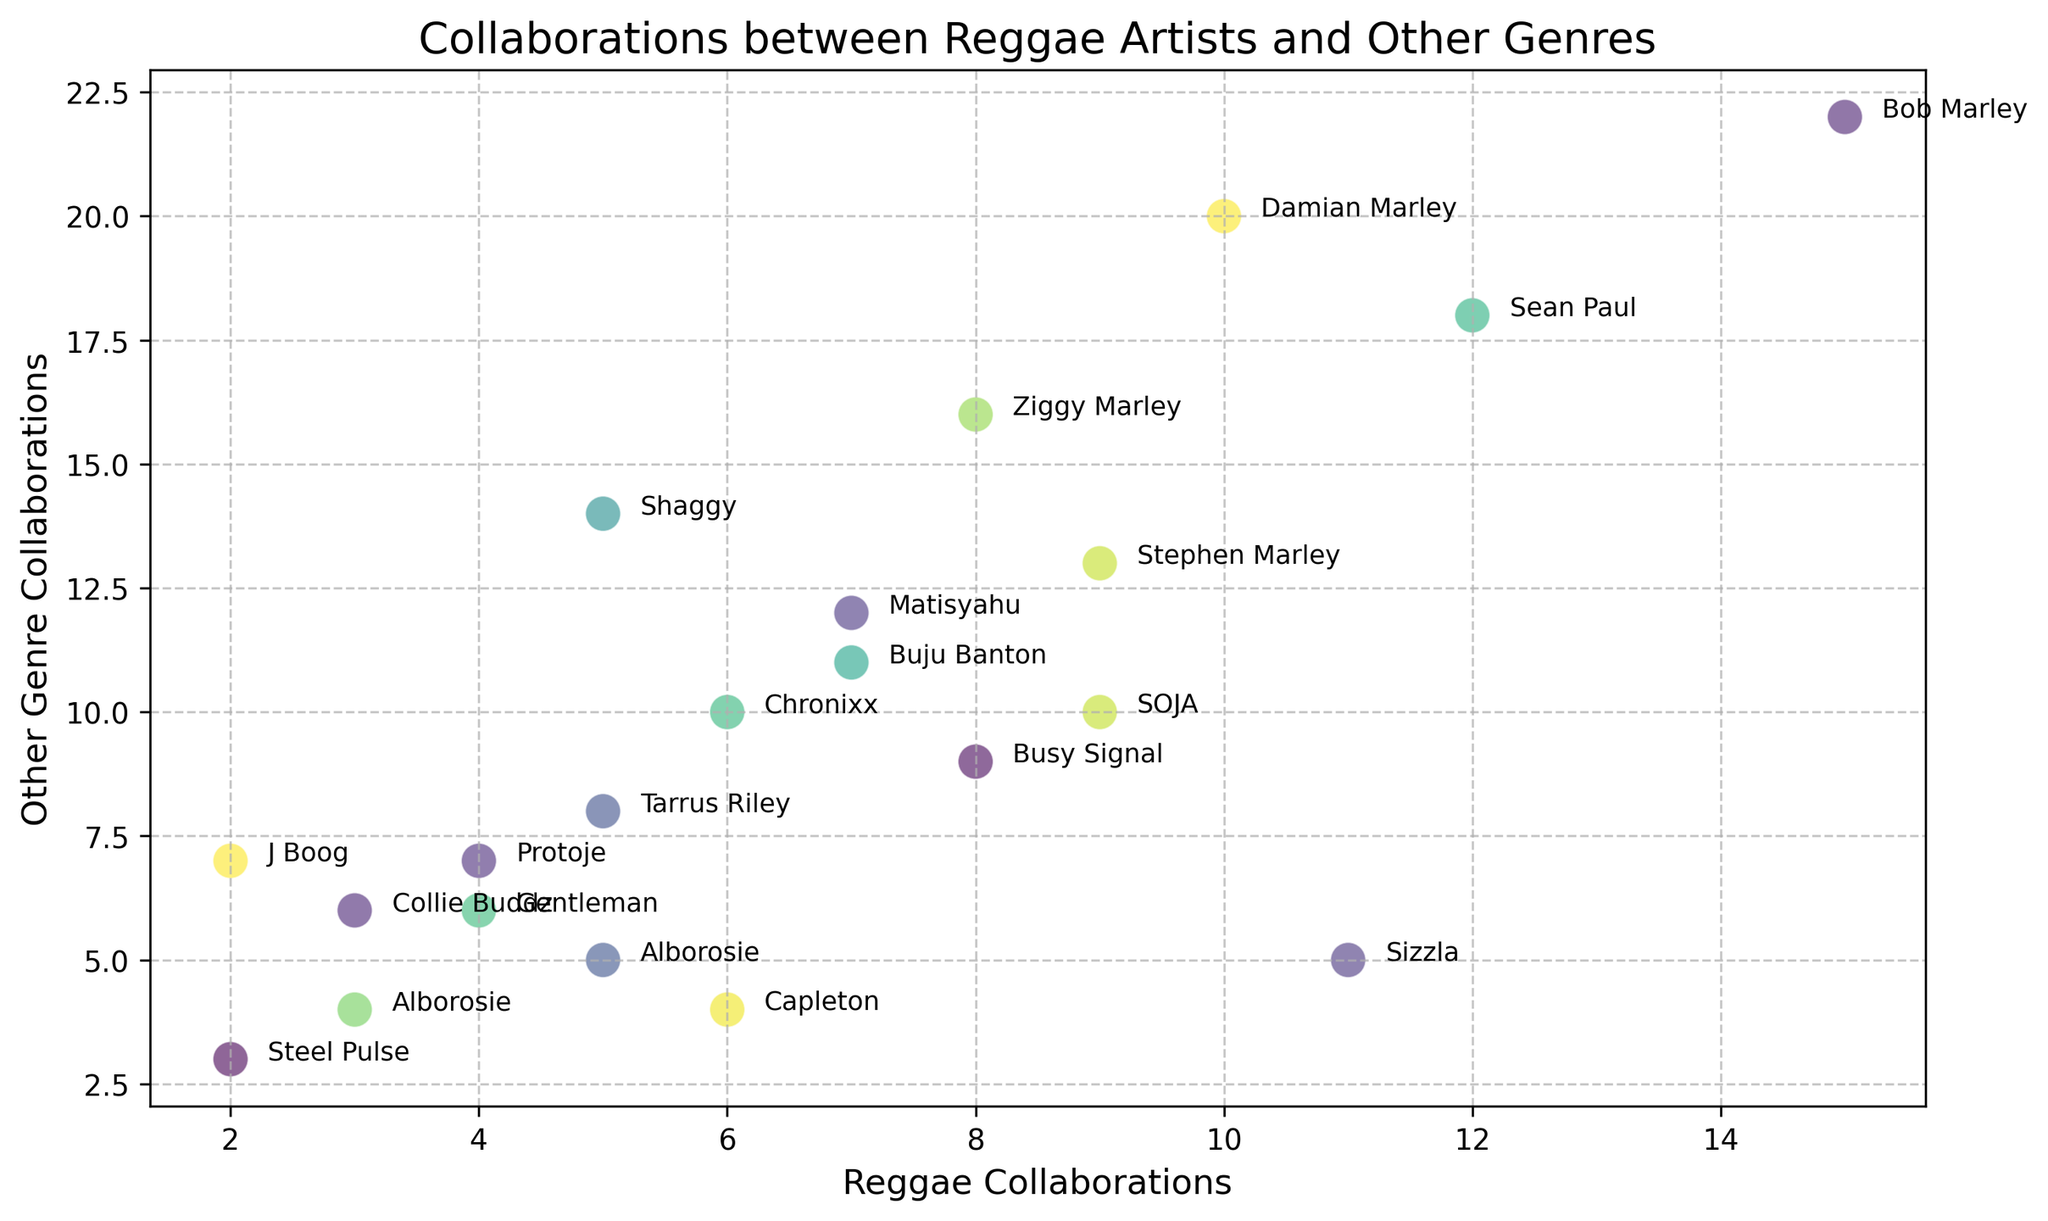What is the total number of reggae collaboration singles for artists who have also released at least 15 singles in other genres? First, identify the artists with at least 15 singles in other genres: Bob Marley (22), Sean Paul (18), Damian Marley (20), and Ziggy Marley (16). Then sum their reggae collaborations: 15 (Bob Marley) + 12 (Sean Paul) + 10 (Damian Marley) + 8 (Ziggy Marley) = 45.
Answer: 45 Which artist has the most number of singles in other genres? Look at the data points to identify which artist has the highest Y-coordinate value. Bob Marley is at the highest position with 22 singles in other genres.
Answer: Bob Marley Who has more reggae collaboration singles: Stephen Marley or Tarrus Riley? Compare the X-coordinate values for Stephen Marley (9) and Tarrus Riley (5). Stephen Marley has more reggae collaboration singles.
Answer: Stephen Marley Which artist has the closest number of reggae and other genre collaboration singles? Look for the data point where the X and Y values are closest. Gentleman has 4 reggae and 6 other genre singles, a difference of 2, which is the closest.
Answer: Gentleman What is the average number of other genre singles for the artists with at least 10 reggae collaboration singles? Identify the artists with at least 10 reggae singles: Bob Marley (15), Sean Paul (12), Damian Marley (10), Sizzla (11). Now, average their other genre singles: (22 + 18 + 20 + 5) / 4 = 16.25.
Answer: 16.25 Which artist with fewer than 10 reggae collaboration singles has collaborated the least in other genres? Identify artists with fewer than 10 reggae singles: Shaggy, Tarrus Riley, Protoje, Steel Pulse, Collie Buddz, J Boog, Alborosie, Gentleman, Matisyahu, Chronixx, Buju Banton. Of these, Steel Pulse has the least with 3 other genre singles.
Answer: Steel Pulse Who are the artists clustered towards the bottom right of the scatter plot? Look towards the segment of the plot with low X values but relatively high Y values. J Boog, Protoje, and Shaggy are clustered in this region.
Answer: J Boog, Protoje, Shaggy What is the difference in the number of other genre singles between Sizzla and J Boog? Sizzla has 5 other genre singles and J Boog has 7. The difference is 7 - 5 = 2.
Answer: 2 Which artists have exactly equal numbers of reggae and other genre collaboration singles? Look for matching X and Y values on the scatter plot. Alborosie and Alborosie (duplicate entry) both have equal numbers: 5 reggae and 5 other genre singles (first entry), 3 reggae and 4 other genre singles (second entry).
Answer: Alborosie (first entry) What is the combined number of other genre singles for Busy Signal and SOJA? Add the Y values for Busy Signal (9) and SOJA (10): 9 + 10 = 19.
Answer: 19 